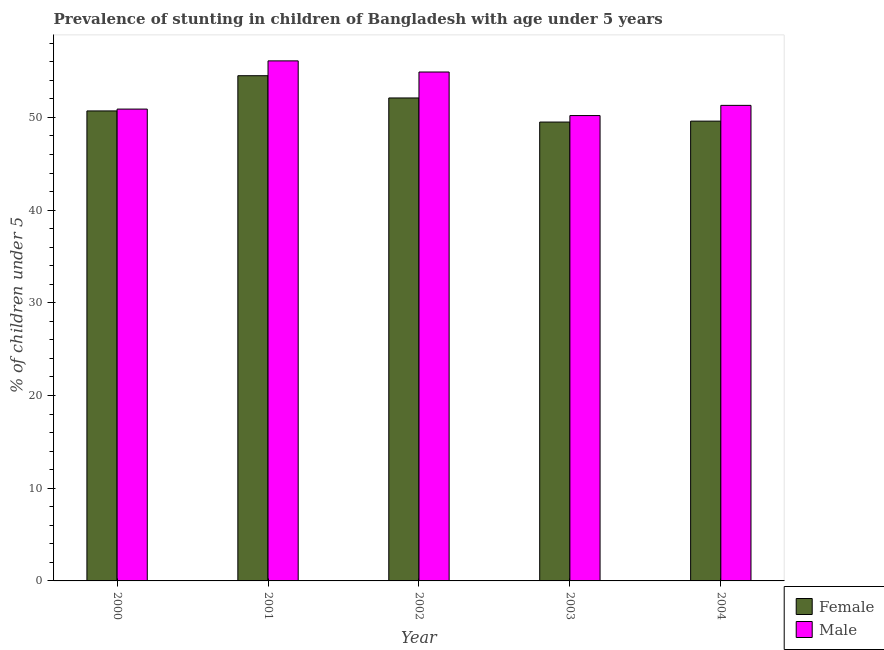How many groups of bars are there?
Your response must be concise. 5. Are the number of bars per tick equal to the number of legend labels?
Provide a succinct answer. Yes. Are the number of bars on each tick of the X-axis equal?
Offer a terse response. Yes. What is the label of the 3rd group of bars from the left?
Provide a short and direct response. 2002. What is the percentage of stunted female children in 2003?
Your answer should be very brief. 49.5. Across all years, what is the maximum percentage of stunted female children?
Ensure brevity in your answer.  54.5. Across all years, what is the minimum percentage of stunted male children?
Offer a very short reply. 50.2. In which year was the percentage of stunted female children maximum?
Keep it short and to the point. 2001. In which year was the percentage of stunted male children minimum?
Keep it short and to the point. 2003. What is the total percentage of stunted female children in the graph?
Your answer should be compact. 256.4. What is the difference between the percentage of stunted male children in 2003 and the percentage of stunted female children in 2000?
Keep it short and to the point. -0.7. What is the average percentage of stunted male children per year?
Offer a terse response. 52.68. In the year 2001, what is the difference between the percentage of stunted female children and percentage of stunted male children?
Offer a terse response. 0. In how many years, is the percentage of stunted female children greater than 22 %?
Provide a short and direct response. 5. What is the ratio of the percentage of stunted male children in 2000 to that in 2002?
Offer a terse response. 0.93. What is the difference between the highest and the second highest percentage of stunted male children?
Provide a short and direct response. 1.2. How many bars are there?
Your response must be concise. 10. Are all the bars in the graph horizontal?
Make the answer very short. No. How many years are there in the graph?
Provide a succinct answer. 5. Are the values on the major ticks of Y-axis written in scientific E-notation?
Offer a terse response. No. Does the graph contain any zero values?
Keep it short and to the point. No. Does the graph contain grids?
Your response must be concise. No. Where does the legend appear in the graph?
Your response must be concise. Bottom right. How many legend labels are there?
Ensure brevity in your answer.  2. How are the legend labels stacked?
Make the answer very short. Vertical. What is the title of the graph?
Provide a short and direct response. Prevalence of stunting in children of Bangladesh with age under 5 years. Does "Mineral" appear as one of the legend labels in the graph?
Your response must be concise. No. What is the label or title of the X-axis?
Offer a terse response. Year. What is the label or title of the Y-axis?
Make the answer very short.  % of children under 5. What is the  % of children under 5 of Female in 2000?
Your answer should be compact. 50.7. What is the  % of children under 5 of Male in 2000?
Provide a succinct answer. 50.9. What is the  % of children under 5 in Female in 2001?
Make the answer very short. 54.5. What is the  % of children under 5 of Male in 2001?
Your response must be concise. 56.1. What is the  % of children under 5 of Female in 2002?
Give a very brief answer. 52.1. What is the  % of children under 5 of Male in 2002?
Offer a terse response. 54.9. What is the  % of children under 5 in Female in 2003?
Your response must be concise. 49.5. What is the  % of children under 5 of Male in 2003?
Keep it short and to the point. 50.2. What is the  % of children under 5 of Female in 2004?
Make the answer very short. 49.6. What is the  % of children under 5 of Male in 2004?
Give a very brief answer. 51.3. Across all years, what is the maximum  % of children under 5 in Female?
Offer a terse response. 54.5. Across all years, what is the maximum  % of children under 5 of Male?
Your response must be concise. 56.1. Across all years, what is the minimum  % of children under 5 in Female?
Offer a very short reply. 49.5. Across all years, what is the minimum  % of children under 5 in Male?
Give a very brief answer. 50.2. What is the total  % of children under 5 of Female in the graph?
Your answer should be very brief. 256.4. What is the total  % of children under 5 in Male in the graph?
Offer a very short reply. 263.4. What is the difference between the  % of children under 5 of Female in 2000 and that in 2001?
Keep it short and to the point. -3.8. What is the difference between the  % of children under 5 of Male in 2000 and that in 2001?
Your answer should be compact. -5.2. What is the difference between the  % of children under 5 in Female in 2000 and that in 2002?
Provide a succinct answer. -1.4. What is the difference between the  % of children under 5 of Female in 2000 and that in 2004?
Your answer should be very brief. 1.1. What is the difference between the  % of children under 5 in Male in 2000 and that in 2004?
Provide a short and direct response. -0.4. What is the difference between the  % of children under 5 of Male in 2001 and that in 2002?
Keep it short and to the point. 1.2. What is the difference between the  % of children under 5 in Female in 2001 and that in 2004?
Your answer should be compact. 4.9. What is the difference between the  % of children under 5 of Male in 2001 and that in 2004?
Make the answer very short. 4.8. What is the difference between the  % of children under 5 of Male in 2002 and that in 2003?
Your answer should be very brief. 4.7. What is the difference between the  % of children under 5 of Male in 2002 and that in 2004?
Provide a short and direct response. 3.6. What is the difference between the  % of children under 5 in Female in 2003 and that in 2004?
Your answer should be very brief. -0.1. What is the difference between the  % of children under 5 in Male in 2003 and that in 2004?
Offer a terse response. -1.1. What is the difference between the  % of children under 5 in Female in 2000 and the  % of children under 5 in Male in 2001?
Keep it short and to the point. -5.4. What is the difference between the  % of children under 5 of Female in 2000 and the  % of children under 5 of Male in 2002?
Make the answer very short. -4.2. What is the difference between the  % of children under 5 of Female in 2002 and the  % of children under 5 of Male in 2004?
Your response must be concise. 0.8. What is the average  % of children under 5 in Female per year?
Ensure brevity in your answer.  51.28. What is the average  % of children under 5 of Male per year?
Offer a terse response. 52.68. In the year 2001, what is the difference between the  % of children under 5 of Female and  % of children under 5 of Male?
Offer a very short reply. -1.6. In the year 2002, what is the difference between the  % of children under 5 of Female and  % of children under 5 of Male?
Ensure brevity in your answer.  -2.8. In the year 2003, what is the difference between the  % of children under 5 in Female and  % of children under 5 in Male?
Your answer should be compact. -0.7. In the year 2004, what is the difference between the  % of children under 5 of Female and  % of children under 5 of Male?
Your answer should be compact. -1.7. What is the ratio of the  % of children under 5 in Female in 2000 to that in 2001?
Offer a very short reply. 0.93. What is the ratio of the  % of children under 5 in Male in 2000 to that in 2001?
Your response must be concise. 0.91. What is the ratio of the  % of children under 5 in Female in 2000 to that in 2002?
Ensure brevity in your answer.  0.97. What is the ratio of the  % of children under 5 of Male in 2000 to that in 2002?
Your answer should be compact. 0.93. What is the ratio of the  % of children under 5 in Female in 2000 to that in 2003?
Keep it short and to the point. 1.02. What is the ratio of the  % of children under 5 of Male in 2000 to that in 2003?
Make the answer very short. 1.01. What is the ratio of the  % of children under 5 of Female in 2000 to that in 2004?
Ensure brevity in your answer.  1.02. What is the ratio of the  % of children under 5 in Female in 2001 to that in 2002?
Make the answer very short. 1.05. What is the ratio of the  % of children under 5 of Male in 2001 to that in 2002?
Your response must be concise. 1.02. What is the ratio of the  % of children under 5 in Female in 2001 to that in 2003?
Your answer should be compact. 1.1. What is the ratio of the  % of children under 5 of Male in 2001 to that in 2003?
Offer a terse response. 1.12. What is the ratio of the  % of children under 5 of Female in 2001 to that in 2004?
Your response must be concise. 1.1. What is the ratio of the  % of children under 5 of Male in 2001 to that in 2004?
Your answer should be very brief. 1.09. What is the ratio of the  % of children under 5 of Female in 2002 to that in 2003?
Keep it short and to the point. 1.05. What is the ratio of the  % of children under 5 in Male in 2002 to that in 2003?
Make the answer very short. 1.09. What is the ratio of the  % of children under 5 of Female in 2002 to that in 2004?
Offer a very short reply. 1.05. What is the ratio of the  % of children under 5 in Male in 2002 to that in 2004?
Your answer should be compact. 1.07. What is the ratio of the  % of children under 5 of Male in 2003 to that in 2004?
Offer a terse response. 0.98. What is the difference between the highest and the second highest  % of children under 5 in Male?
Make the answer very short. 1.2. What is the difference between the highest and the lowest  % of children under 5 of Female?
Make the answer very short. 5. 